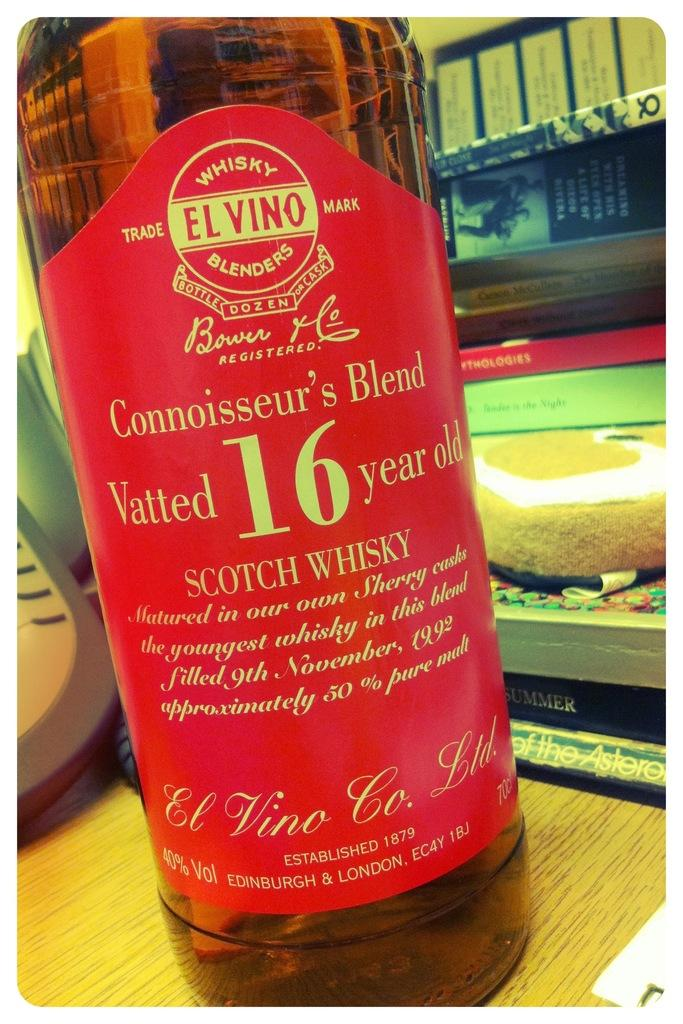<image>
Write a terse but informative summary of the picture. A bottle of Scotch Wiskey has a nice red label 